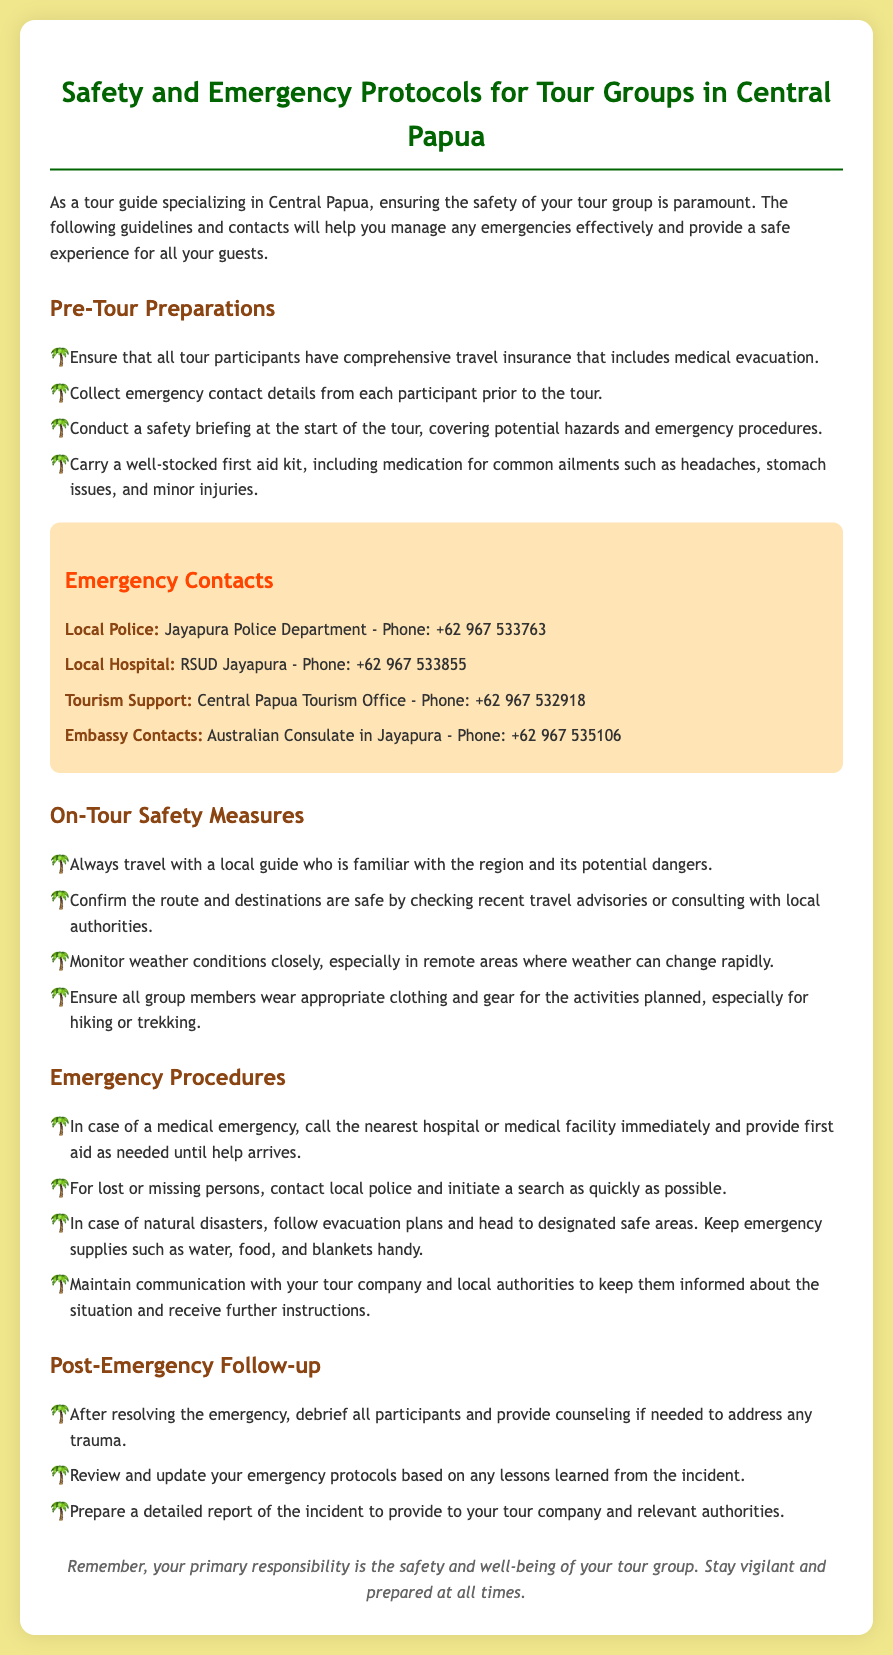what is the title of the document? The title of the document is the main heading that describes its content and purpose.
Answer: Safety and Emergency Protocols for Tour Groups in Central Papua how many emergency contacts are listed? The emergency contacts are specific individuals or organizations that can be reached during an emergency, and the document lists four of them.
Answer: 4 what is the phone number for the local hospital? The phone number is a crucial piece of information for emergencies and is specifically provided in the document for the local hospital.
Answer: +62 967 533855 what should participants carry for safety during the tour? This includes specific items mentioned in the document that are essential for handling medical issues during the tour.
Answer: comprehensive travel insurance what action should be taken for a medical emergency? This question addresses the specific procedure outlined in the document related to medical emergencies during the tour.
Answer: call the nearest hospital who should travel with the tour group? The answer pertains to the type of individual mentioned in the document that ensures the group's safety throughout the tour.
Answer: a local guide how should participants be prepared for activities? This reflects the recommendations in the document regarding the appropriate attire for different activities.
Answer: wear appropriate clothing and gear what is the purpose of post-emergency follow-up? The purpose pertains to the activities conducted after an emergency as outlined in the document to ensure safety and healing.
Answer: debrief all participants what should be included in the safety briefing? This reflects the essential information that tour guides need to convey to participants at the start of the tour to enhance safety.
Answer: potential hazards and emergency procedures 